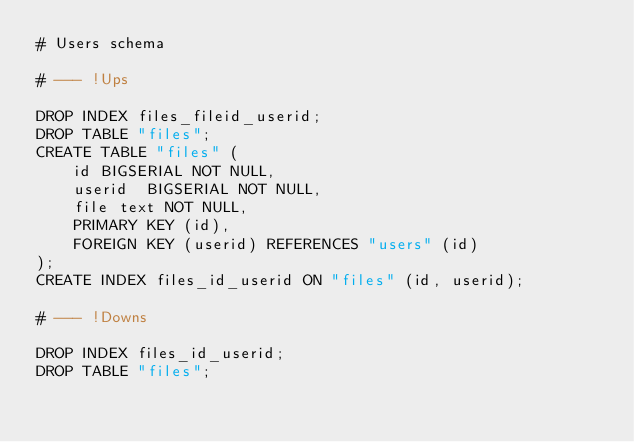Convert code to text. <code><loc_0><loc_0><loc_500><loc_500><_SQL_># Users schema

# --- !Ups

DROP INDEX files_fileid_userid;
DROP TABLE "files";
CREATE TABLE "files" (
    id BIGSERIAL NOT NULL,
    userid  BIGSERIAL NOT NULL,
    file text NOT NULL,
    PRIMARY KEY (id),
    FOREIGN KEY (userid) REFERENCES "users" (id)
);
CREATE INDEX files_id_userid ON "files" (id, userid);

# --- !Downs

DROP INDEX files_id_userid;
DROP TABLE "files";
</code> 